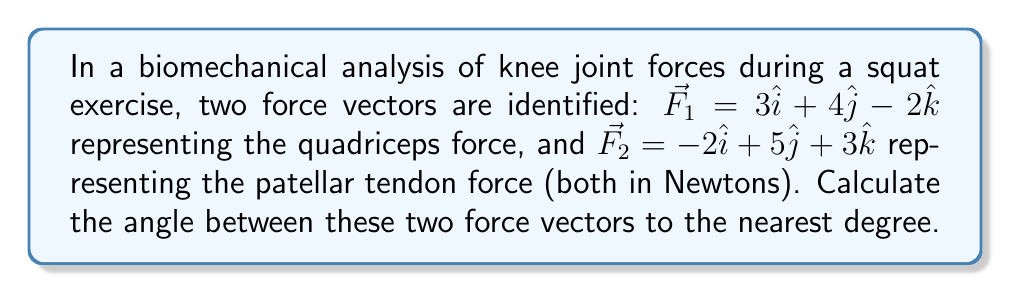Provide a solution to this math problem. To find the angle between two vectors, we can use the dot product formula:

$$\cos \theta = \frac{\vec{F_1} \cdot \vec{F_2}}{|\vec{F_1}| |\vec{F_2}|}$$

Step 1: Calculate the dot product $\vec{F_1} \cdot \vec{F_2}$
$$\vec{F_1} \cdot \vec{F_2} = (3)(-2) + (4)(5) + (-2)(3) = -6 + 20 - 6 = 8$$

Step 2: Calculate the magnitudes of $\vec{F_1}$ and $\vec{F_2}$
$$|\vec{F_1}| = \sqrt{3^2 + 4^2 + (-2)^2} = \sqrt{9 + 16 + 4} = \sqrt{29}$$
$$|\vec{F_2}| = \sqrt{(-2)^2 + 5^2 + 3^2} = \sqrt{4 + 25 + 9} = \sqrt{38}$$

Step 3: Substitute into the dot product formula
$$\cos \theta = \frac{8}{\sqrt{29} \sqrt{38}}$$

Step 4: Solve for $\theta$ using inverse cosine
$$\theta = \arccos\left(\frac{8}{\sqrt{29} \sqrt{38}}\right)$$

Step 5: Calculate and round to the nearest degree
$$\theta \approx 70.5^\circ \approx 71^\circ$$
Answer: $71^\circ$ 